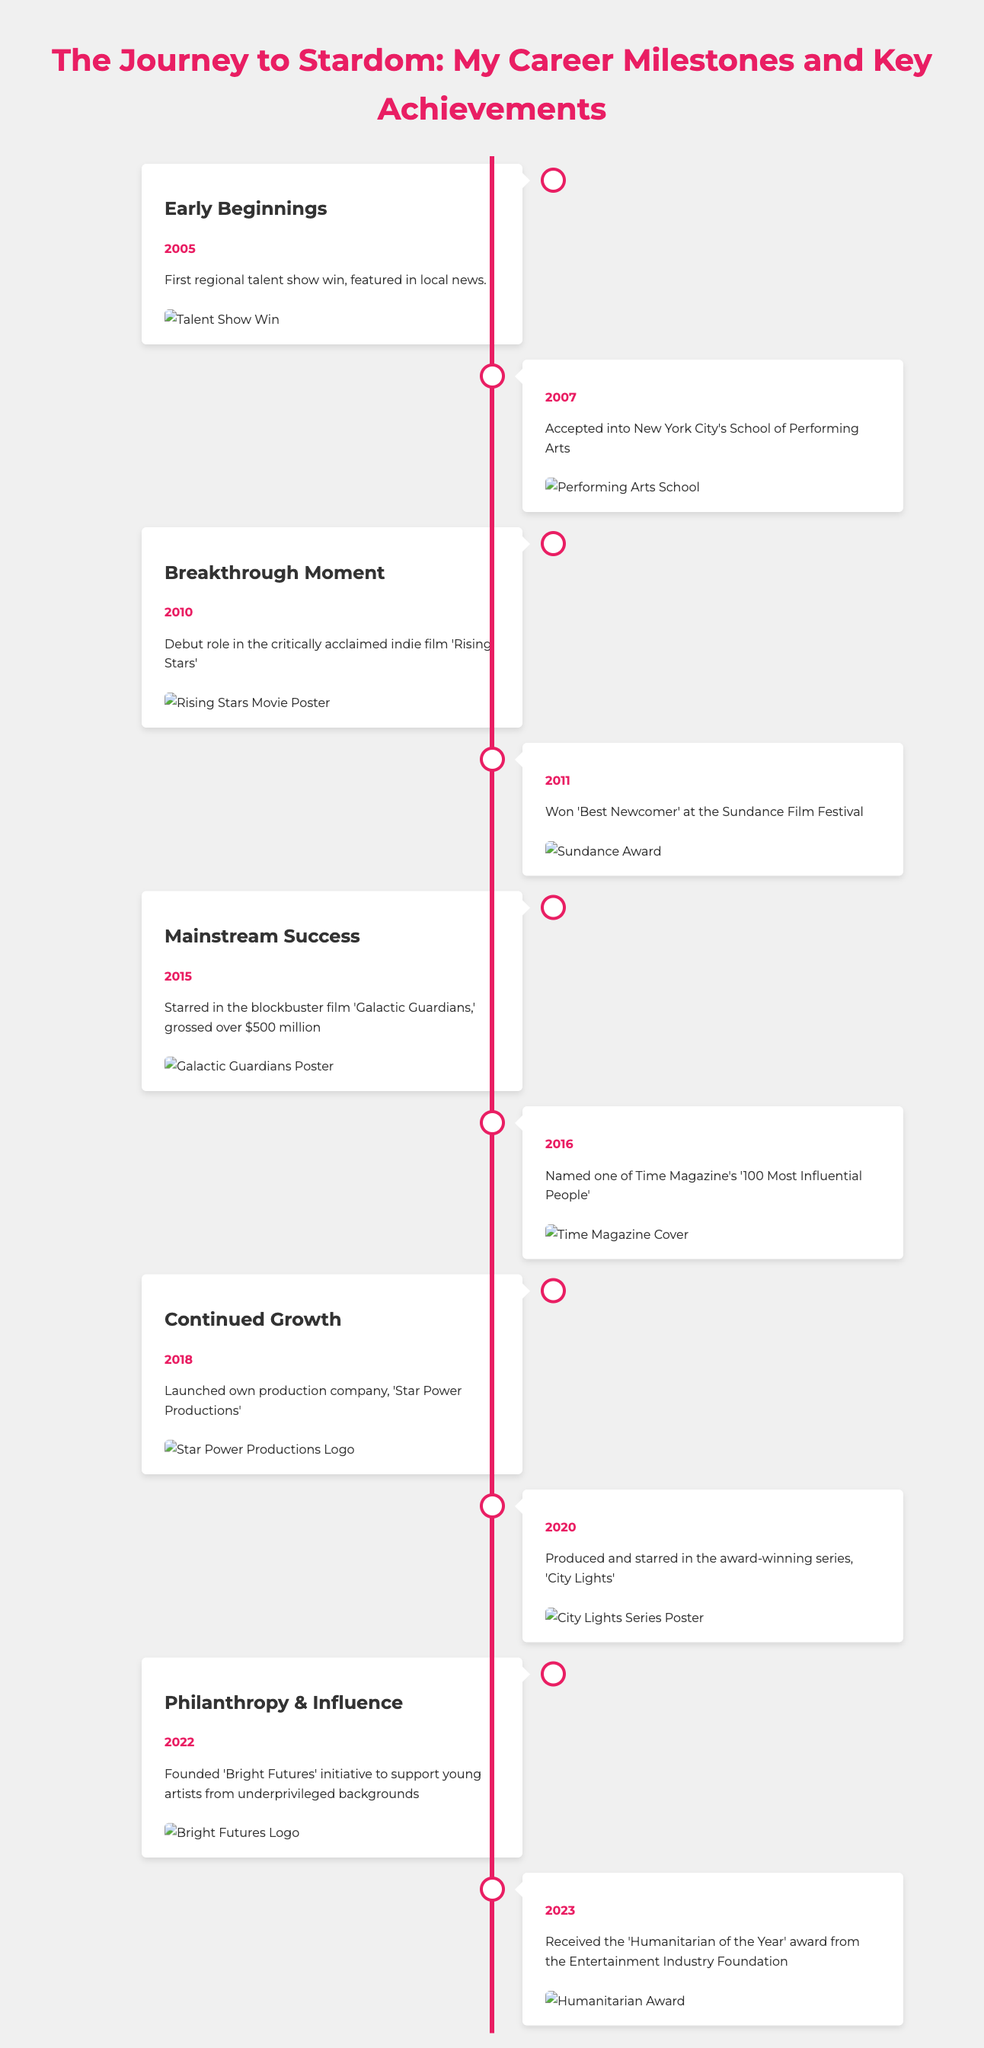What year did the first regional talent show win occur? The milestone of the first regional talent show win is noted in the year 2005.
Answer: 2005 What award was won at the Sundance Film Festival? The award noted in the document is 'Best Newcomer' at the Sundance Film Festival.
Answer: Best Newcomer Which blockbuster film grossed over $500 million? The film that is mentioned as grossing over $500 million is 'Galactic Guardians'.
Answer: Galactic Guardians What initiative was founded to support young artists? The document details the founding of the 'Bright Futures' initiative to support young artists from underprivileged backgrounds.
Answer: Bright Futures In which year was the production company launched? The launch of the production company 'Star Power Productions' occurred in 2018.
Answer: 2018 What significant recognition did the individual receive in 2016? In 2016, the individual was named one of Time Magazine's '100 Most Influential People'.
Answer: 100 Most Influential People What was the theme of the milestone labelled 'Philanthropy & Influence'? The milestone focuses on charitable efforts, specifically the founding of an initiative to support young artists.
Answer: Support for young artists How many years did it take from the first talent show win to mainstream success? Mainstream success began in 2015, with the first talent show win occurring in 2005, making it a span of 10 years.
Answer: 10 years What major award did the individual receive in 2023? The document states that the major award received in 2023 is the 'Humanitarian of the Year' award.
Answer: Humanitarian of the Year 